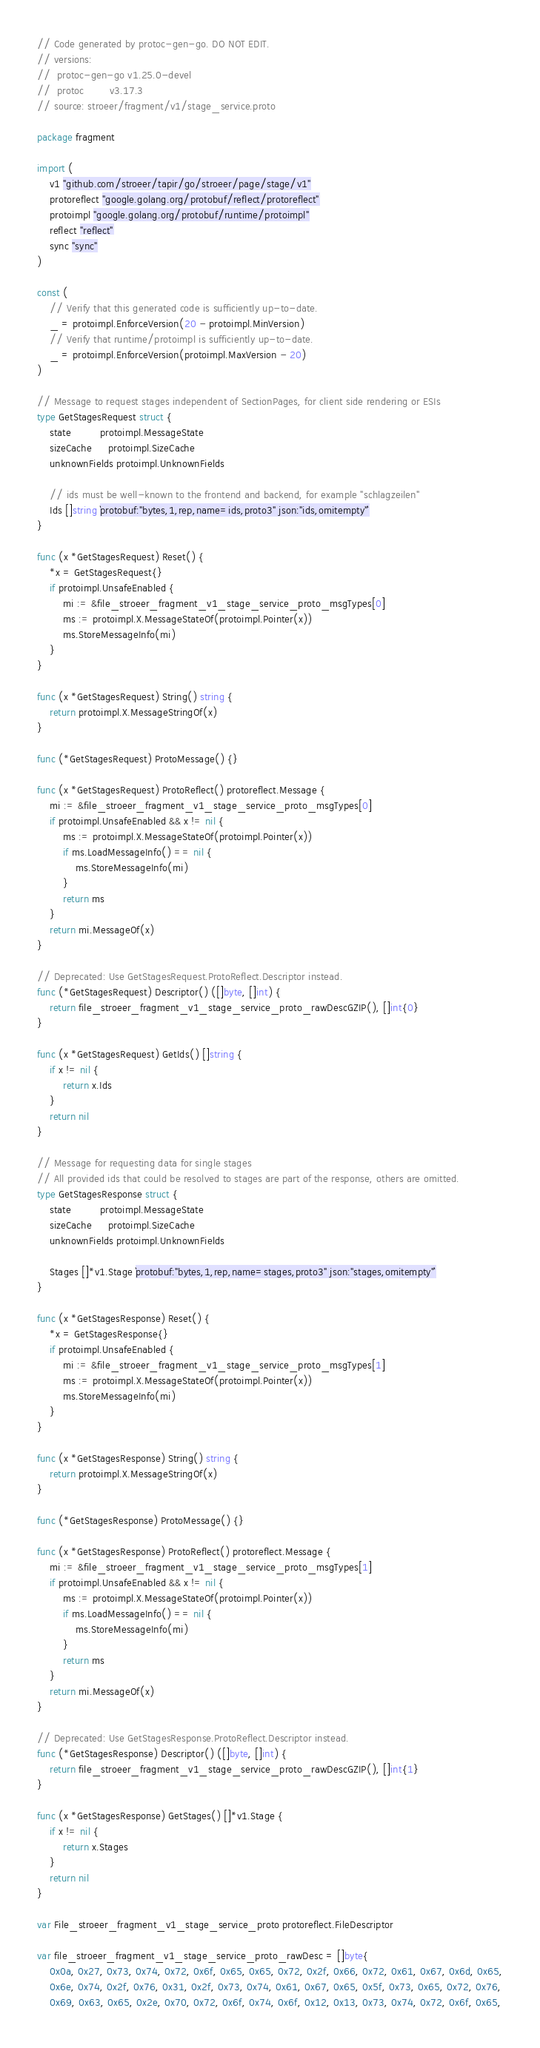<code> <loc_0><loc_0><loc_500><loc_500><_Go_>// Code generated by protoc-gen-go. DO NOT EDIT.
// versions:
// 	protoc-gen-go v1.25.0-devel
// 	protoc        v3.17.3
// source: stroeer/fragment/v1/stage_service.proto

package fragment

import (
	v1 "github.com/stroeer/tapir/go/stroeer/page/stage/v1"
	protoreflect "google.golang.org/protobuf/reflect/protoreflect"
	protoimpl "google.golang.org/protobuf/runtime/protoimpl"
	reflect "reflect"
	sync "sync"
)

const (
	// Verify that this generated code is sufficiently up-to-date.
	_ = protoimpl.EnforceVersion(20 - protoimpl.MinVersion)
	// Verify that runtime/protoimpl is sufficiently up-to-date.
	_ = protoimpl.EnforceVersion(protoimpl.MaxVersion - 20)
)

// Message to request stages independent of SectionPages, for client side rendering or ESIs
type GetStagesRequest struct {
	state         protoimpl.MessageState
	sizeCache     protoimpl.SizeCache
	unknownFields protoimpl.UnknownFields

	// ids must be well-known to the frontend and backend, for example "schlagzeilen"
	Ids []string `protobuf:"bytes,1,rep,name=ids,proto3" json:"ids,omitempty"`
}

func (x *GetStagesRequest) Reset() {
	*x = GetStagesRequest{}
	if protoimpl.UnsafeEnabled {
		mi := &file_stroeer_fragment_v1_stage_service_proto_msgTypes[0]
		ms := protoimpl.X.MessageStateOf(protoimpl.Pointer(x))
		ms.StoreMessageInfo(mi)
	}
}

func (x *GetStagesRequest) String() string {
	return protoimpl.X.MessageStringOf(x)
}

func (*GetStagesRequest) ProtoMessage() {}

func (x *GetStagesRequest) ProtoReflect() protoreflect.Message {
	mi := &file_stroeer_fragment_v1_stage_service_proto_msgTypes[0]
	if protoimpl.UnsafeEnabled && x != nil {
		ms := protoimpl.X.MessageStateOf(protoimpl.Pointer(x))
		if ms.LoadMessageInfo() == nil {
			ms.StoreMessageInfo(mi)
		}
		return ms
	}
	return mi.MessageOf(x)
}

// Deprecated: Use GetStagesRequest.ProtoReflect.Descriptor instead.
func (*GetStagesRequest) Descriptor() ([]byte, []int) {
	return file_stroeer_fragment_v1_stage_service_proto_rawDescGZIP(), []int{0}
}

func (x *GetStagesRequest) GetIds() []string {
	if x != nil {
		return x.Ids
	}
	return nil
}

// Message for requesting data for single stages
// All provided ids that could be resolved to stages are part of the response, others are omitted.
type GetStagesResponse struct {
	state         protoimpl.MessageState
	sizeCache     protoimpl.SizeCache
	unknownFields protoimpl.UnknownFields

	Stages []*v1.Stage `protobuf:"bytes,1,rep,name=stages,proto3" json:"stages,omitempty"`
}

func (x *GetStagesResponse) Reset() {
	*x = GetStagesResponse{}
	if protoimpl.UnsafeEnabled {
		mi := &file_stroeer_fragment_v1_stage_service_proto_msgTypes[1]
		ms := protoimpl.X.MessageStateOf(protoimpl.Pointer(x))
		ms.StoreMessageInfo(mi)
	}
}

func (x *GetStagesResponse) String() string {
	return protoimpl.X.MessageStringOf(x)
}

func (*GetStagesResponse) ProtoMessage() {}

func (x *GetStagesResponse) ProtoReflect() protoreflect.Message {
	mi := &file_stroeer_fragment_v1_stage_service_proto_msgTypes[1]
	if protoimpl.UnsafeEnabled && x != nil {
		ms := protoimpl.X.MessageStateOf(protoimpl.Pointer(x))
		if ms.LoadMessageInfo() == nil {
			ms.StoreMessageInfo(mi)
		}
		return ms
	}
	return mi.MessageOf(x)
}

// Deprecated: Use GetStagesResponse.ProtoReflect.Descriptor instead.
func (*GetStagesResponse) Descriptor() ([]byte, []int) {
	return file_stroeer_fragment_v1_stage_service_proto_rawDescGZIP(), []int{1}
}

func (x *GetStagesResponse) GetStages() []*v1.Stage {
	if x != nil {
		return x.Stages
	}
	return nil
}

var File_stroeer_fragment_v1_stage_service_proto protoreflect.FileDescriptor

var file_stroeer_fragment_v1_stage_service_proto_rawDesc = []byte{
	0x0a, 0x27, 0x73, 0x74, 0x72, 0x6f, 0x65, 0x65, 0x72, 0x2f, 0x66, 0x72, 0x61, 0x67, 0x6d, 0x65,
	0x6e, 0x74, 0x2f, 0x76, 0x31, 0x2f, 0x73, 0x74, 0x61, 0x67, 0x65, 0x5f, 0x73, 0x65, 0x72, 0x76,
	0x69, 0x63, 0x65, 0x2e, 0x70, 0x72, 0x6f, 0x74, 0x6f, 0x12, 0x13, 0x73, 0x74, 0x72, 0x6f, 0x65,</code> 